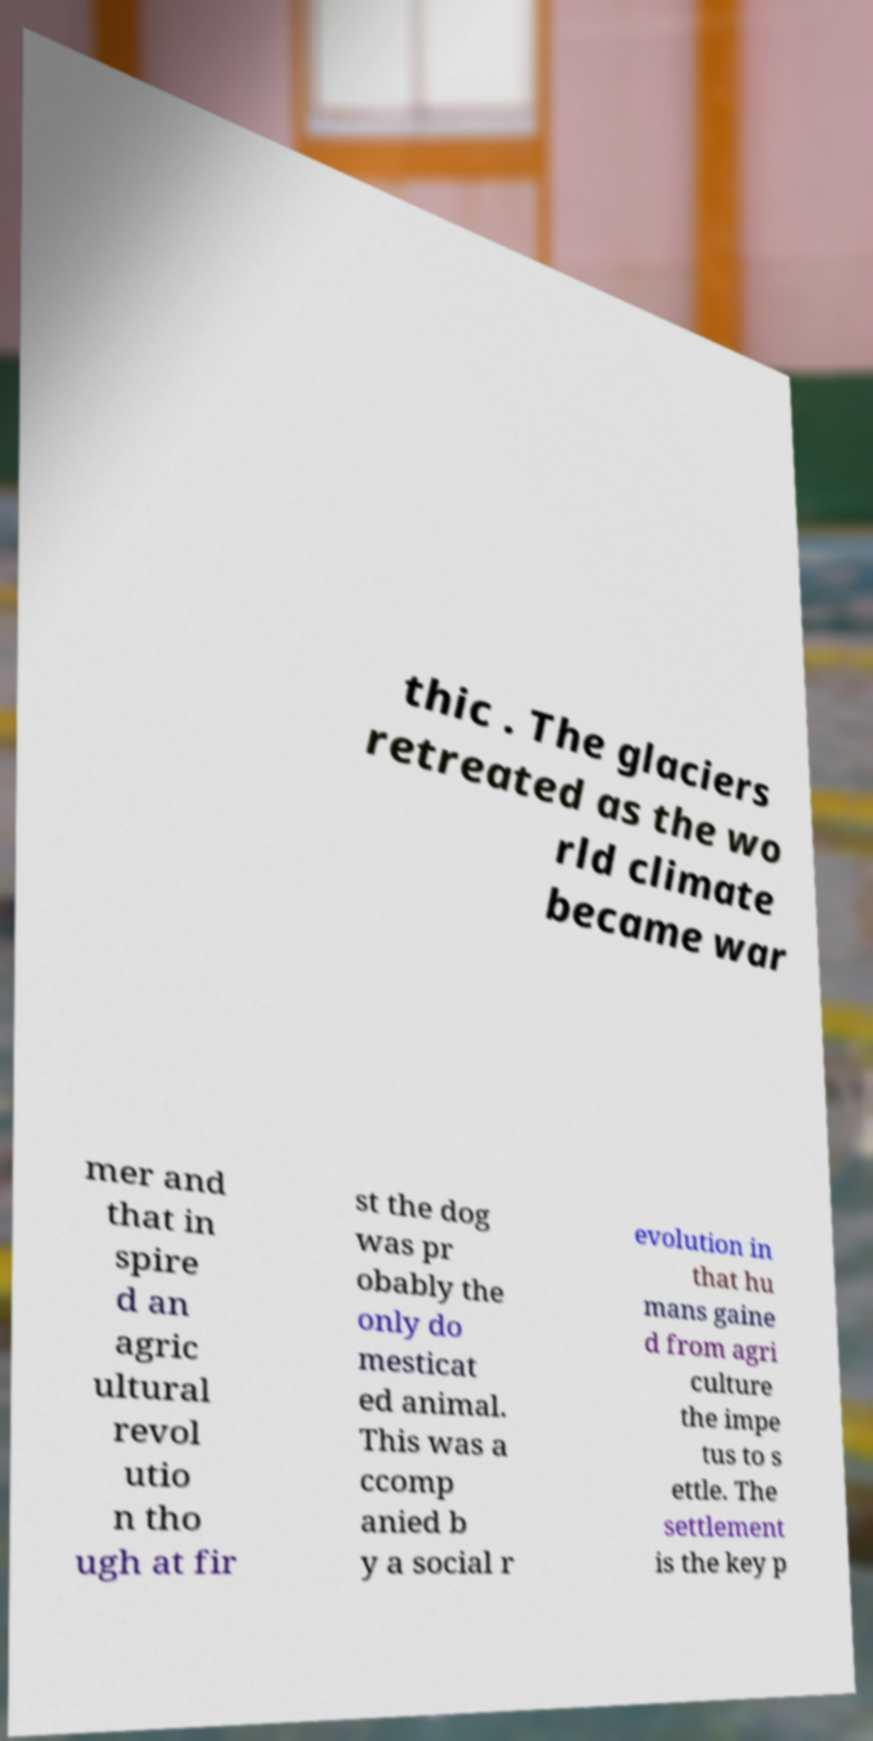Could you extract and type out the text from this image? thic . The glaciers retreated as the wo rld climate became war mer and that in spire d an agric ultural revol utio n tho ugh at fir st the dog was pr obably the only do mesticat ed animal. This was a ccomp anied b y a social r evolution in that hu mans gaine d from agri culture the impe tus to s ettle. The settlement is the key p 